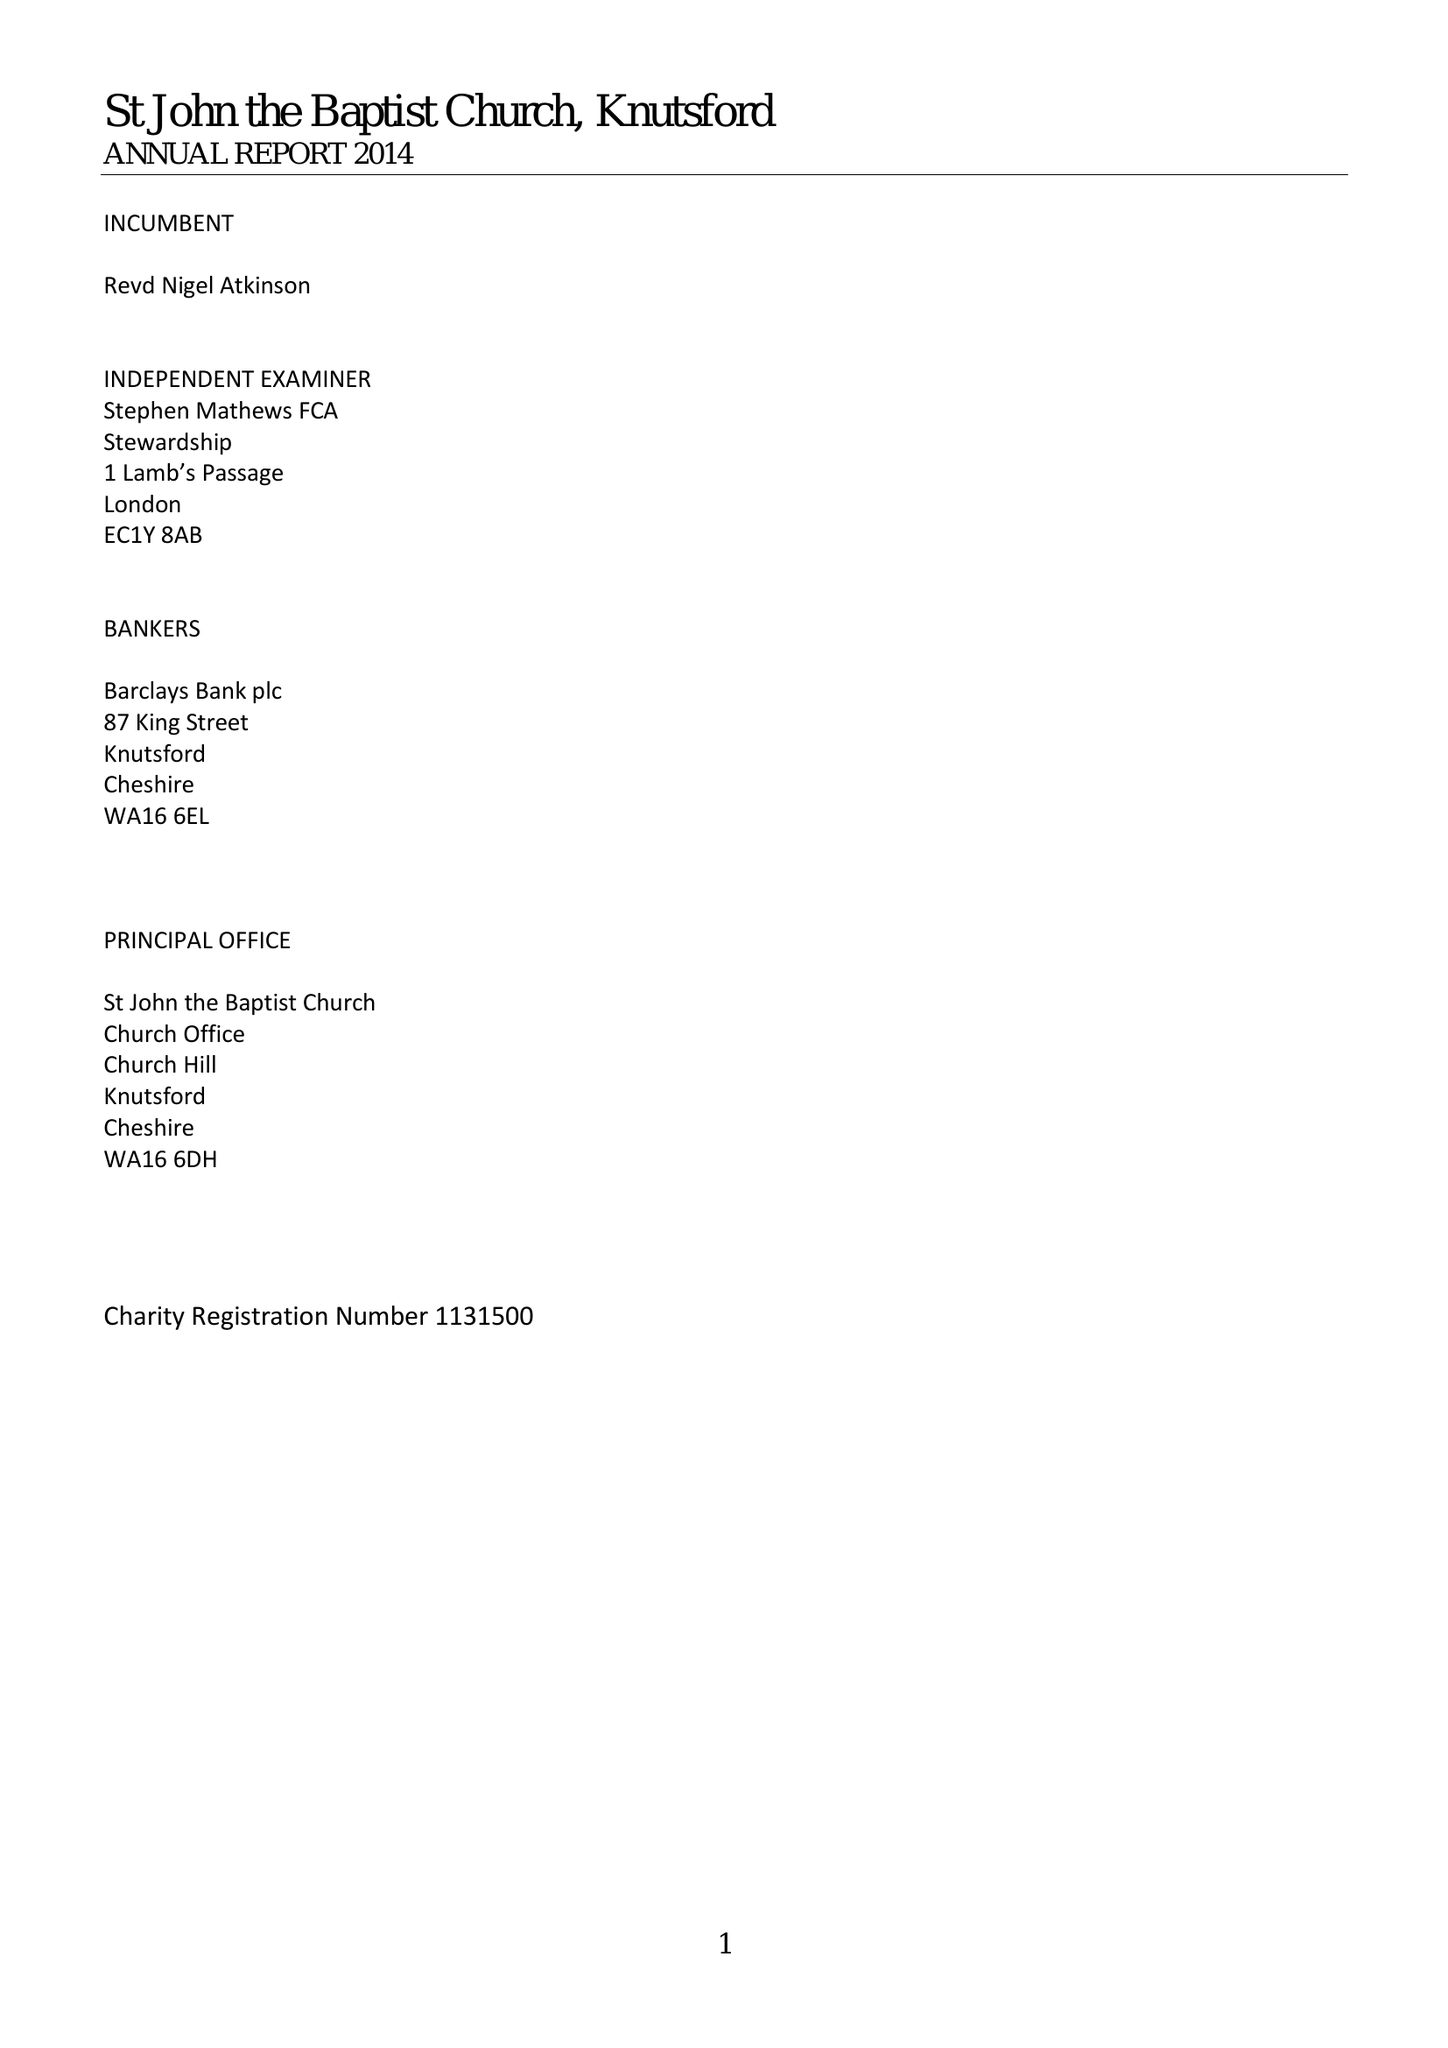What is the value for the report_date?
Answer the question using a single word or phrase. 2014-12-31 